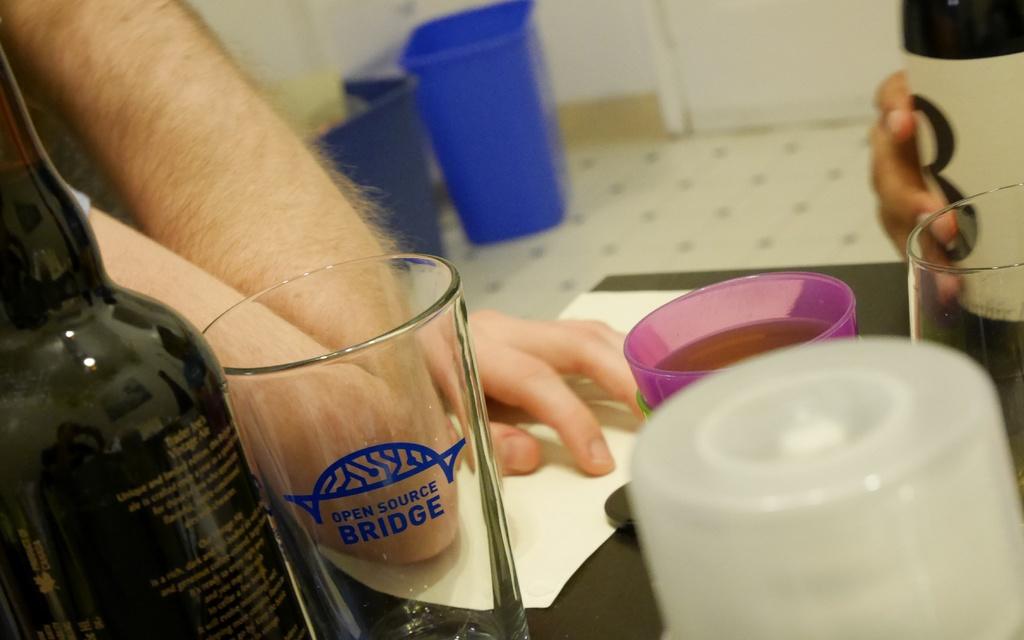In which country was the bottle on the left manufactured?
Provide a short and direct response. Unanswerable. 